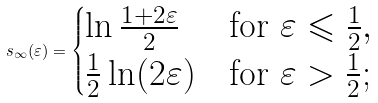<formula> <loc_0><loc_0><loc_500><loc_500>s _ { \infty } ( \varepsilon ) = \begin{cases} \ln \frac { 1 + 2 \varepsilon } { 2 } & \text {for $\varepsilon\leqslant\frac{1}{2}$} , \\ \frac { 1 } { 2 } \ln ( 2 \varepsilon ) & \text {for $\varepsilon > \frac{1}{2}$} ; \end{cases}</formula> 